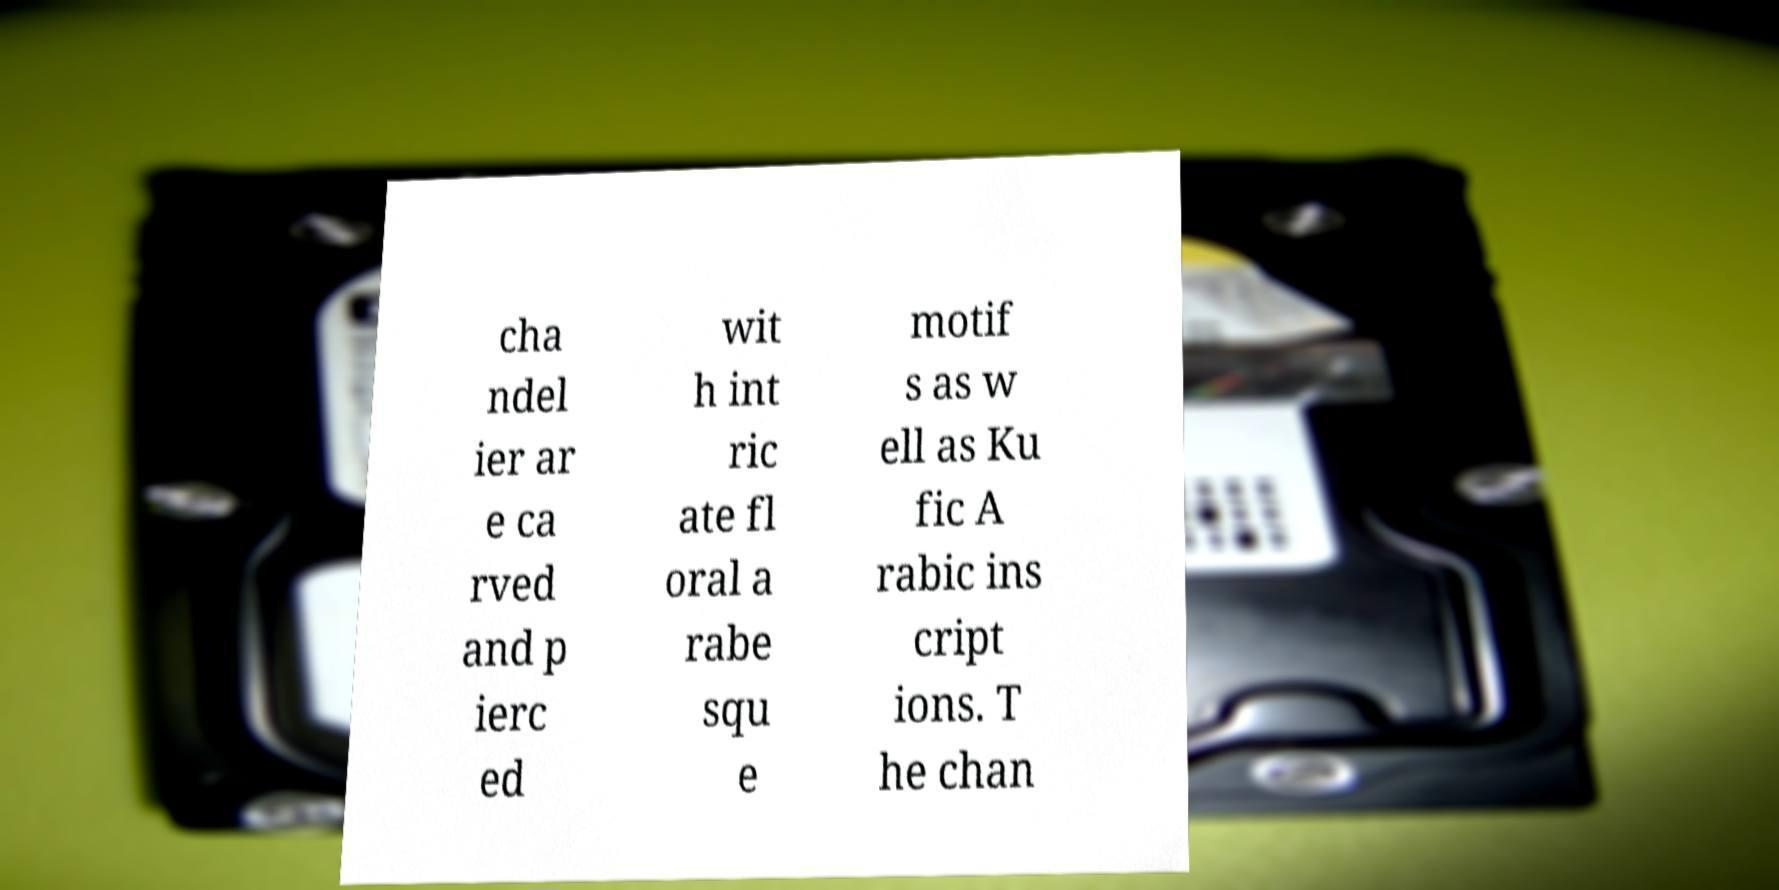Please identify and transcribe the text found in this image. cha ndel ier ar e ca rved and p ierc ed wit h int ric ate fl oral a rabe squ e motif s as w ell as Ku fic A rabic ins cript ions. T he chan 